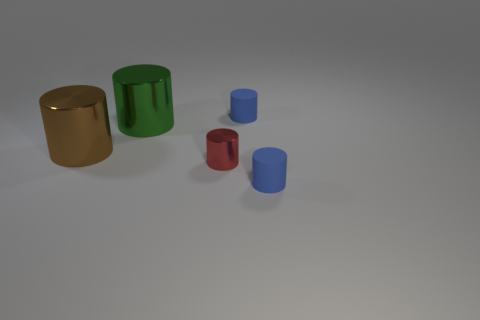Are there more blue matte objects that are behind the big green thing than green blocks?
Give a very brief answer. Yes. Is there any other thing of the same color as the tiny metallic cylinder?
Keep it short and to the point. No. There is a blue object that is behind the matte cylinder in front of the small red thing; what is its shape?
Provide a short and direct response. Cylinder. Are there more large green cylinders than small yellow cubes?
Your response must be concise. Yes. What number of shiny things are right of the brown metallic object and left of the tiny red thing?
Your answer should be very brief. 1. There is a tiny blue cylinder behind the large green shiny thing; how many red metal things are behind it?
Offer a very short reply. 0. How many objects are either blue matte cylinders behind the green metallic thing or things that are in front of the red object?
Your answer should be compact. 2. What number of things are either metallic cylinders in front of the big green cylinder or tiny blue things?
Make the answer very short. 4. What number of big metal objects are the same shape as the small red metallic thing?
Provide a short and direct response. 2. What is the big brown cylinder made of?
Make the answer very short. Metal. 